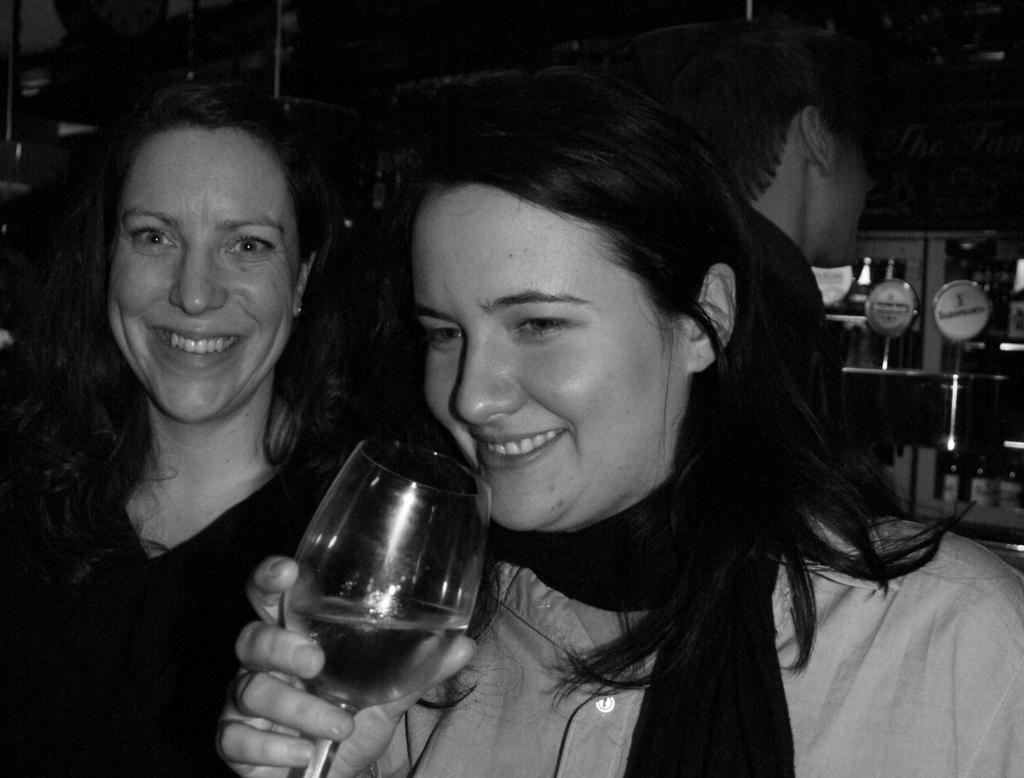How many people are in the image? There are two persons standing in the middle of the image. What are the people in the image doing? Both persons are smiling. What is one person holding in the image? One person is holding a glass. Can you describe the position of the man in the image? There is a man standing behind the woman. What is visible in the top right side of the image? There is a door in the top right side of the image. What type of account is the man opening for the woman in the image? There is no indication in the image that the man is opening an account for the woman. 